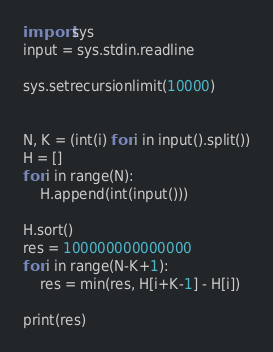<code> <loc_0><loc_0><loc_500><loc_500><_Python_>import sys
input = sys.stdin.readline

sys.setrecursionlimit(10000)


N, K = (int(i) for i in input().split())
H = []
for i in range(N):
    H.append(int(input()))

H.sort()
res = 100000000000000
for i in range(N-K+1):
    res = min(res, H[i+K-1] - H[i])

print(res)</code> 